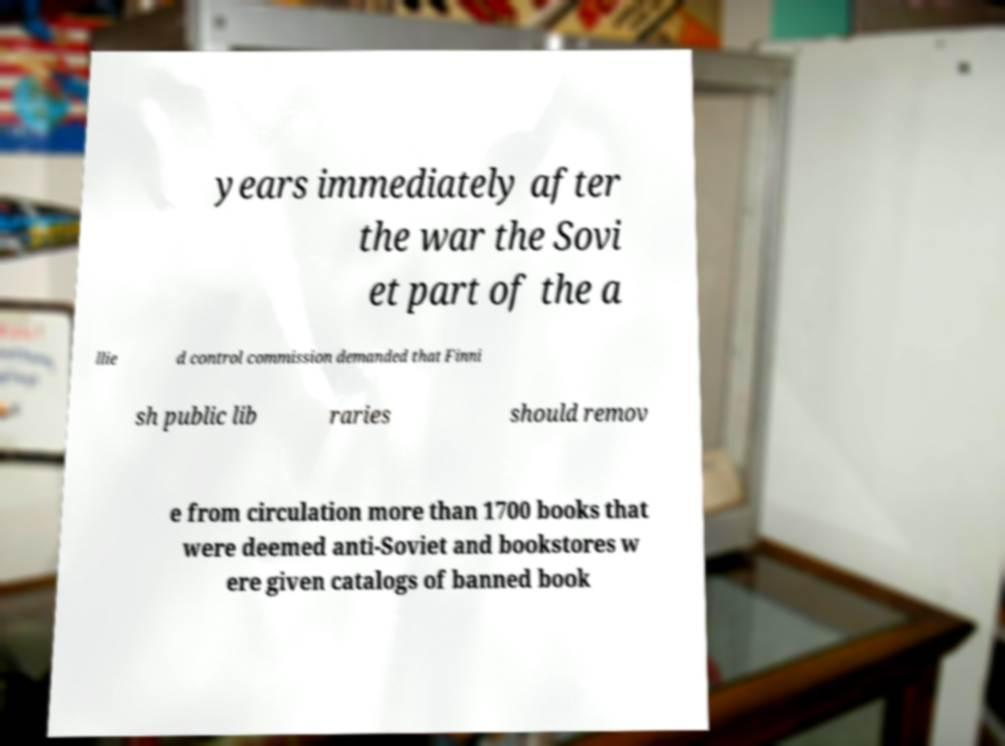Please identify and transcribe the text found in this image. years immediately after the war the Sovi et part of the a llie d control commission demanded that Finni sh public lib raries should remov e from circulation more than 1700 books that were deemed anti-Soviet and bookstores w ere given catalogs of banned book 